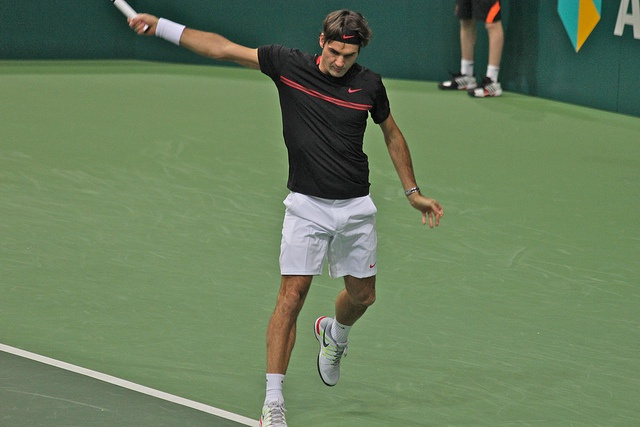Describe the objects in this image and their specific colors. I can see people in black, darkgray, and gray tones, people in black, gray, and darkgray tones, and tennis racket in black, lightgray, darkgray, and gray tones in this image. 